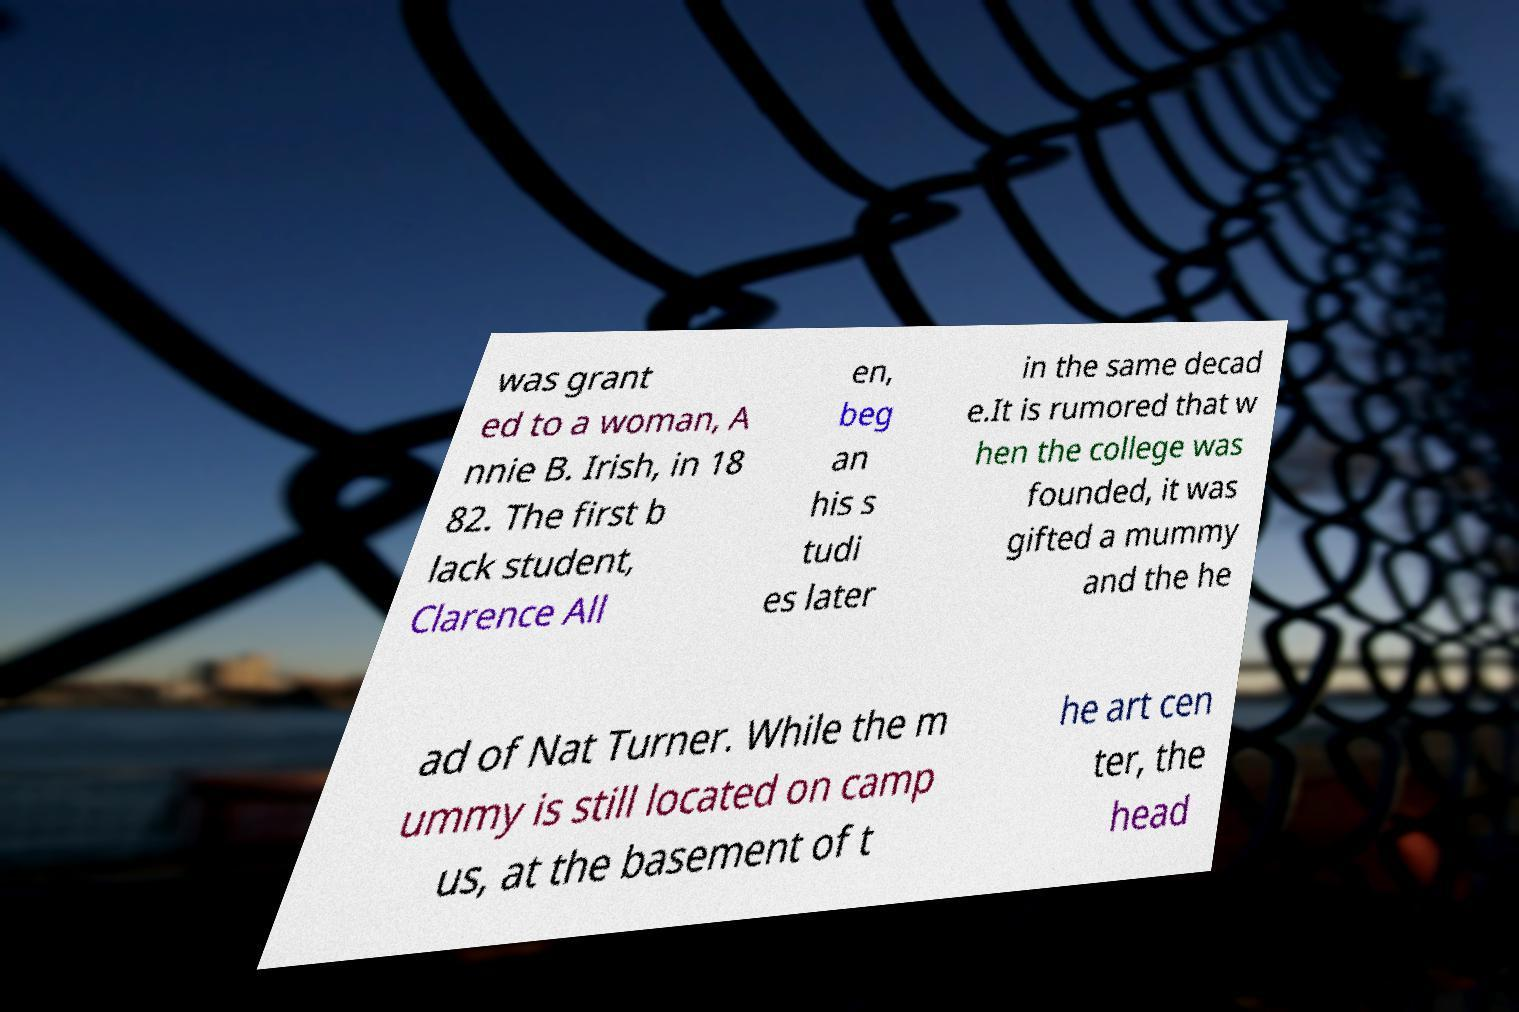There's text embedded in this image that I need extracted. Can you transcribe it verbatim? was grant ed to a woman, A nnie B. Irish, in 18 82. The first b lack student, Clarence All en, beg an his s tudi es later in the same decad e.It is rumored that w hen the college was founded, it was gifted a mummy and the he ad of Nat Turner. While the m ummy is still located on camp us, at the basement of t he art cen ter, the head 